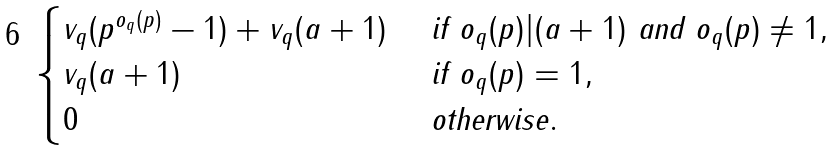Convert formula to latex. <formula><loc_0><loc_0><loc_500><loc_500>\begin{cases} v _ { q } ( p ^ { o _ { q } ( p ) } - 1 ) + v _ { q } ( a + 1 ) & \text { if } o _ { q } ( p ) | ( a + 1 ) \text { and } o _ { q } ( p ) \neq 1 , \\ v _ { q } ( a + 1 ) & \text { if } o _ { q } ( p ) = 1 , \\ 0 & \text { otherwise} . \end{cases}</formula> 